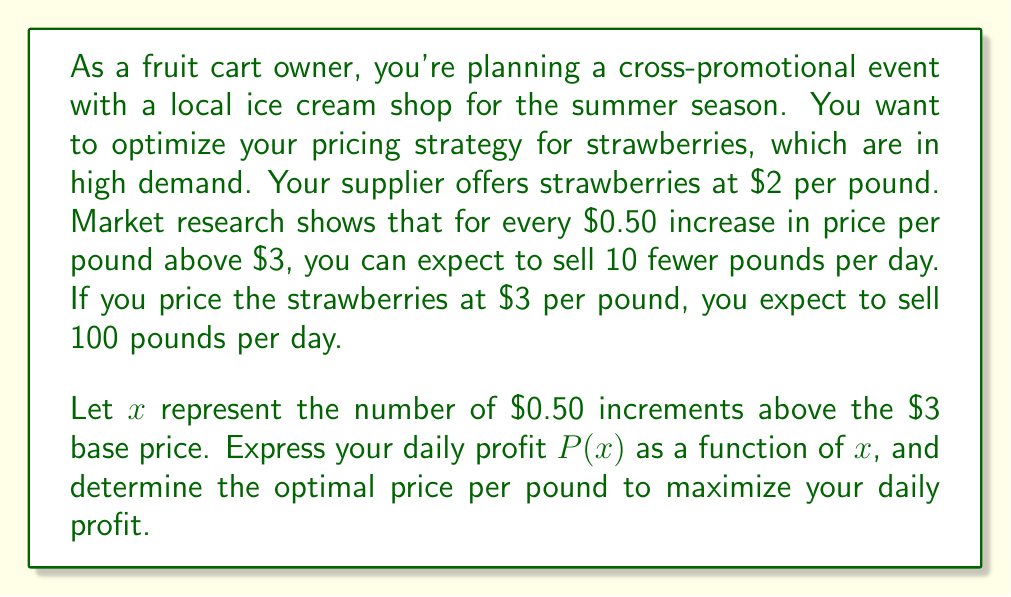Solve this math problem. Let's approach this step-by-step:

1) First, let's define our variables:
   $x$ = number of $0.50 increments above $3
   $p$ = price per pound = $3 + 0.50x$
   $q$ = quantity sold per day = $100 - 10x$

2) Revenue function:
   $R(x) = pq = (3 + 0.50x)(100 - 10x)$

3) Cost function:
   $C(x) = 2(100 - 10x)$ (as we pay $2 per pound to the supplier)

4) Profit function:
   $$P(x) = R(x) - C(x)$$
   $$P(x) = (3 + 0.50x)(100 - 10x) - 2(100 - 10x)$$
   $$P(x) = 300 + 50x - 30x - 5x^2 - 200 + 20x$$
   $$P(x) = 100 + 40x - 5x^2$$

5) To find the maximum profit, we differentiate $P(x)$ and set it to zero:
   $$\frac{dP}{dx} = 40 - 10x$$
   $$40 - 10x = 0$$
   $$x = 4$$

6) The second derivative is negative ($-10$), confirming this is a maximum.

7) Optimal number of $0.50 increments = 4
   Optimal price = $3 + (4 * $0.50) = $5 per pound

8) Maximum daily profit:
   $$P(4) = 100 + 40(4) - 5(4^2) = 100 + 160 - 80 = $180$$
Answer: The optimal price for strawberries is $5 per pound, which will result in a maximum daily profit of $180. 